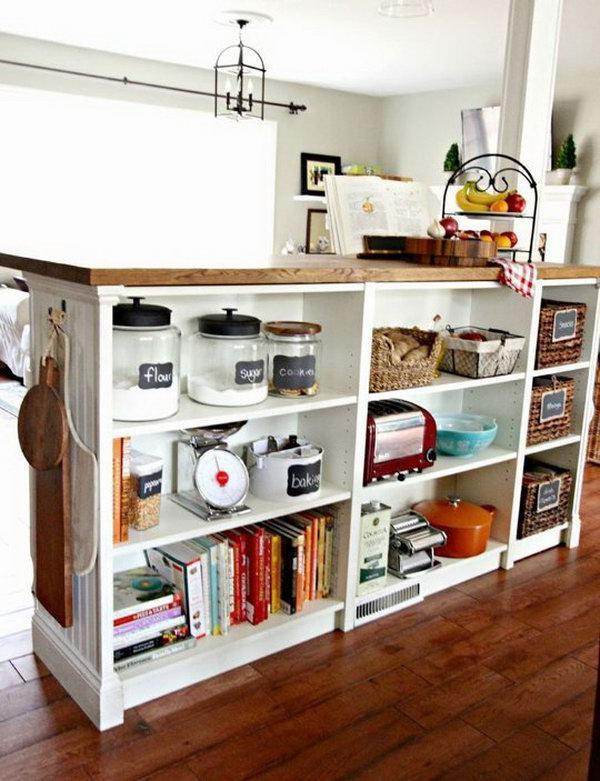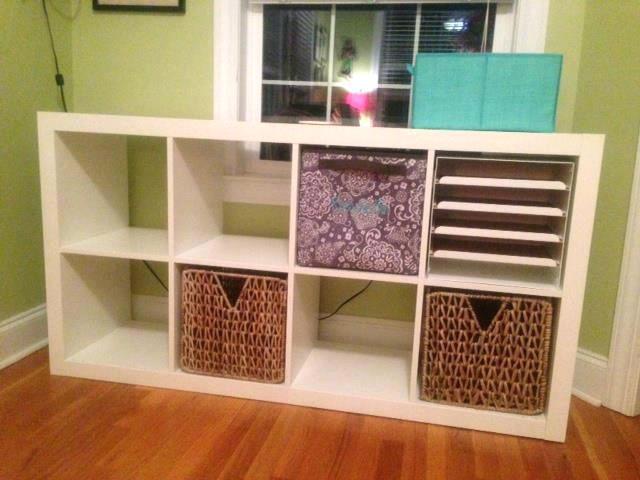The first image is the image on the left, the second image is the image on the right. For the images shown, is this caption "At least one image shows a white cabinet containing some type of sky blue ceramic vessel." true? Answer yes or no. Yes. 